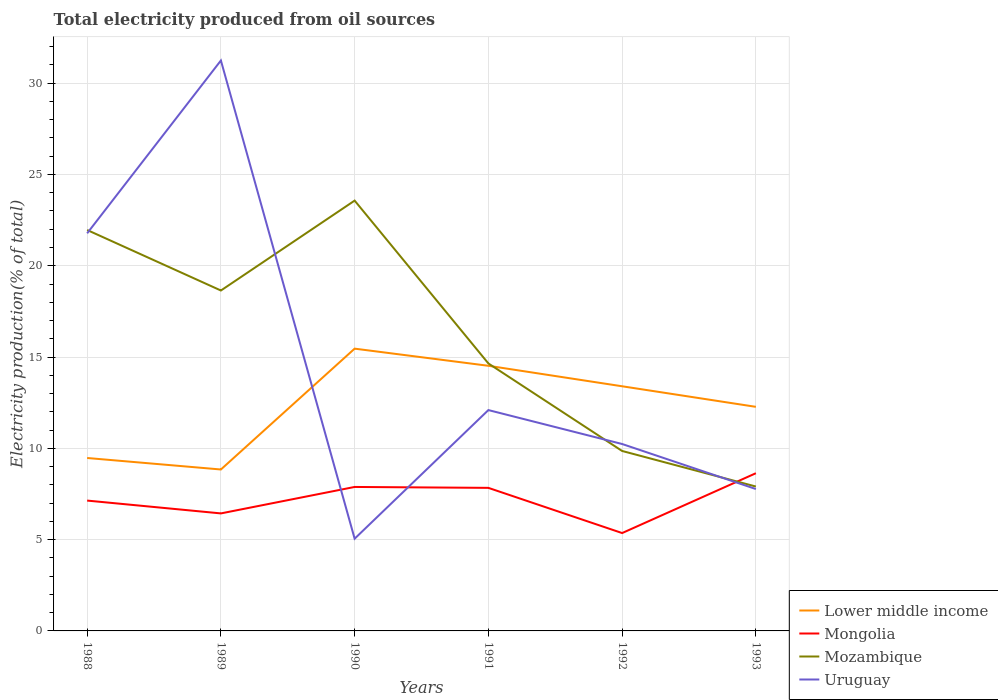Across all years, what is the maximum total electricity produced in Mongolia?
Your answer should be compact. 5.36. In which year was the total electricity produced in Mongolia maximum?
Ensure brevity in your answer.  1992. What is the total total electricity produced in Lower middle income in the graph?
Ensure brevity in your answer.  -3.93. What is the difference between the highest and the second highest total electricity produced in Uruguay?
Give a very brief answer. 26.19. What is the difference between the highest and the lowest total electricity produced in Mozambique?
Your answer should be compact. 3. Is the total electricity produced in Uruguay strictly greater than the total electricity produced in Mozambique over the years?
Give a very brief answer. No. What is the difference between two consecutive major ticks on the Y-axis?
Provide a short and direct response. 5. Does the graph contain any zero values?
Offer a very short reply. No. Does the graph contain grids?
Make the answer very short. Yes. Where does the legend appear in the graph?
Make the answer very short. Bottom right. How are the legend labels stacked?
Your response must be concise. Vertical. What is the title of the graph?
Provide a succinct answer. Total electricity produced from oil sources. What is the label or title of the X-axis?
Ensure brevity in your answer.  Years. What is the Electricity production(% of total) in Lower middle income in 1988?
Keep it short and to the point. 9.47. What is the Electricity production(% of total) of Mongolia in 1988?
Ensure brevity in your answer.  7.14. What is the Electricity production(% of total) in Mozambique in 1988?
Provide a succinct answer. 21.96. What is the Electricity production(% of total) in Uruguay in 1988?
Offer a terse response. 21.78. What is the Electricity production(% of total) of Lower middle income in 1989?
Ensure brevity in your answer.  8.84. What is the Electricity production(% of total) in Mongolia in 1989?
Keep it short and to the point. 6.44. What is the Electricity production(% of total) of Mozambique in 1989?
Provide a succinct answer. 18.64. What is the Electricity production(% of total) in Uruguay in 1989?
Provide a short and direct response. 31.24. What is the Electricity production(% of total) of Lower middle income in 1990?
Your response must be concise. 15.46. What is the Electricity production(% of total) in Mongolia in 1990?
Keep it short and to the point. 7.89. What is the Electricity production(% of total) in Mozambique in 1990?
Your answer should be compact. 23.57. What is the Electricity production(% of total) of Uruguay in 1990?
Offer a very short reply. 5.05. What is the Electricity production(% of total) in Lower middle income in 1991?
Your answer should be compact. 14.52. What is the Electricity production(% of total) of Mongolia in 1991?
Your answer should be very brief. 7.84. What is the Electricity production(% of total) in Mozambique in 1991?
Provide a short and direct response. 14.65. What is the Electricity production(% of total) in Uruguay in 1991?
Keep it short and to the point. 12.1. What is the Electricity production(% of total) of Lower middle income in 1992?
Offer a very short reply. 13.4. What is the Electricity production(% of total) in Mongolia in 1992?
Your response must be concise. 5.36. What is the Electricity production(% of total) of Mozambique in 1992?
Give a very brief answer. 9.86. What is the Electricity production(% of total) of Uruguay in 1992?
Offer a terse response. 10.24. What is the Electricity production(% of total) of Lower middle income in 1993?
Your answer should be very brief. 12.27. What is the Electricity production(% of total) in Mongolia in 1993?
Your response must be concise. 8.64. What is the Electricity production(% of total) of Mozambique in 1993?
Offer a very short reply. 7.91. What is the Electricity production(% of total) in Uruguay in 1993?
Give a very brief answer. 7.77. Across all years, what is the maximum Electricity production(% of total) of Lower middle income?
Provide a succinct answer. 15.46. Across all years, what is the maximum Electricity production(% of total) of Mongolia?
Give a very brief answer. 8.64. Across all years, what is the maximum Electricity production(% of total) in Mozambique?
Ensure brevity in your answer.  23.57. Across all years, what is the maximum Electricity production(% of total) of Uruguay?
Ensure brevity in your answer.  31.24. Across all years, what is the minimum Electricity production(% of total) of Lower middle income?
Your answer should be compact. 8.84. Across all years, what is the minimum Electricity production(% of total) in Mongolia?
Your answer should be compact. 5.36. Across all years, what is the minimum Electricity production(% of total) in Mozambique?
Provide a short and direct response. 7.91. Across all years, what is the minimum Electricity production(% of total) in Uruguay?
Offer a terse response. 5.05. What is the total Electricity production(% of total) of Lower middle income in the graph?
Make the answer very short. 73.97. What is the total Electricity production(% of total) in Mongolia in the graph?
Your answer should be very brief. 43.29. What is the total Electricity production(% of total) of Mozambique in the graph?
Offer a terse response. 96.58. What is the total Electricity production(% of total) in Uruguay in the graph?
Your answer should be compact. 88.17. What is the difference between the Electricity production(% of total) of Lower middle income in 1988 and that in 1989?
Ensure brevity in your answer.  0.63. What is the difference between the Electricity production(% of total) in Mongolia in 1988 and that in 1989?
Give a very brief answer. 0.7. What is the difference between the Electricity production(% of total) in Mozambique in 1988 and that in 1989?
Provide a succinct answer. 3.31. What is the difference between the Electricity production(% of total) of Uruguay in 1988 and that in 1989?
Keep it short and to the point. -9.47. What is the difference between the Electricity production(% of total) in Lower middle income in 1988 and that in 1990?
Ensure brevity in your answer.  -5.99. What is the difference between the Electricity production(% of total) in Mongolia in 1988 and that in 1990?
Provide a succinct answer. -0.75. What is the difference between the Electricity production(% of total) of Mozambique in 1988 and that in 1990?
Provide a succinct answer. -1.61. What is the difference between the Electricity production(% of total) of Uruguay in 1988 and that in 1990?
Give a very brief answer. 16.72. What is the difference between the Electricity production(% of total) in Lower middle income in 1988 and that in 1991?
Provide a short and direct response. -5.05. What is the difference between the Electricity production(% of total) in Mongolia in 1988 and that in 1991?
Your answer should be very brief. -0.7. What is the difference between the Electricity production(% of total) in Mozambique in 1988 and that in 1991?
Make the answer very short. 7.31. What is the difference between the Electricity production(% of total) in Uruguay in 1988 and that in 1991?
Keep it short and to the point. 9.68. What is the difference between the Electricity production(% of total) of Lower middle income in 1988 and that in 1992?
Keep it short and to the point. -3.93. What is the difference between the Electricity production(% of total) of Mongolia in 1988 and that in 1992?
Keep it short and to the point. 1.78. What is the difference between the Electricity production(% of total) of Mozambique in 1988 and that in 1992?
Offer a very short reply. 12.1. What is the difference between the Electricity production(% of total) in Uruguay in 1988 and that in 1992?
Your answer should be compact. 11.54. What is the difference between the Electricity production(% of total) of Lower middle income in 1988 and that in 1993?
Your response must be concise. -2.8. What is the difference between the Electricity production(% of total) in Mongolia in 1988 and that in 1993?
Give a very brief answer. -1.5. What is the difference between the Electricity production(% of total) of Mozambique in 1988 and that in 1993?
Provide a succinct answer. 14.05. What is the difference between the Electricity production(% of total) of Uruguay in 1988 and that in 1993?
Your response must be concise. 14. What is the difference between the Electricity production(% of total) of Lower middle income in 1989 and that in 1990?
Ensure brevity in your answer.  -6.62. What is the difference between the Electricity production(% of total) in Mongolia in 1989 and that in 1990?
Keep it short and to the point. -1.45. What is the difference between the Electricity production(% of total) in Mozambique in 1989 and that in 1990?
Provide a succinct answer. -4.92. What is the difference between the Electricity production(% of total) of Uruguay in 1989 and that in 1990?
Offer a terse response. 26.19. What is the difference between the Electricity production(% of total) of Lower middle income in 1989 and that in 1991?
Ensure brevity in your answer.  -5.68. What is the difference between the Electricity production(% of total) in Mongolia in 1989 and that in 1991?
Offer a very short reply. -1.4. What is the difference between the Electricity production(% of total) in Mozambique in 1989 and that in 1991?
Offer a very short reply. 3.99. What is the difference between the Electricity production(% of total) in Uruguay in 1989 and that in 1991?
Provide a short and direct response. 19.15. What is the difference between the Electricity production(% of total) of Lower middle income in 1989 and that in 1992?
Make the answer very short. -4.56. What is the difference between the Electricity production(% of total) in Mongolia in 1989 and that in 1992?
Your answer should be very brief. 1.08. What is the difference between the Electricity production(% of total) in Mozambique in 1989 and that in 1992?
Your answer should be compact. 8.79. What is the difference between the Electricity production(% of total) in Uruguay in 1989 and that in 1992?
Make the answer very short. 21.01. What is the difference between the Electricity production(% of total) of Lower middle income in 1989 and that in 1993?
Make the answer very short. -3.43. What is the difference between the Electricity production(% of total) of Mongolia in 1989 and that in 1993?
Offer a terse response. -2.2. What is the difference between the Electricity production(% of total) of Mozambique in 1989 and that in 1993?
Your response must be concise. 10.74. What is the difference between the Electricity production(% of total) of Uruguay in 1989 and that in 1993?
Provide a succinct answer. 23.47. What is the difference between the Electricity production(% of total) in Lower middle income in 1990 and that in 1991?
Your response must be concise. 0.94. What is the difference between the Electricity production(% of total) of Mongolia in 1990 and that in 1991?
Keep it short and to the point. 0.05. What is the difference between the Electricity production(% of total) in Mozambique in 1990 and that in 1991?
Your response must be concise. 8.92. What is the difference between the Electricity production(% of total) in Uruguay in 1990 and that in 1991?
Make the answer very short. -7.04. What is the difference between the Electricity production(% of total) of Lower middle income in 1990 and that in 1992?
Your answer should be very brief. 2.06. What is the difference between the Electricity production(% of total) in Mongolia in 1990 and that in 1992?
Ensure brevity in your answer.  2.53. What is the difference between the Electricity production(% of total) of Mozambique in 1990 and that in 1992?
Your answer should be very brief. 13.71. What is the difference between the Electricity production(% of total) in Uruguay in 1990 and that in 1992?
Your answer should be compact. -5.19. What is the difference between the Electricity production(% of total) in Lower middle income in 1990 and that in 1993?
Provide a succinct answer. 3.19. What is the difference between the Electricity production(% of total) in Mongolia in 1990 and that in 1993?
Offer a very short reply. -0.75. What is the difference between the Electricity production(% of total) of Mozambique in 1990 and that in 1993?
Offer a very short reply. 15.66. What is the difference between the Electricity production(% of total) in Uruguay in 1990 and that in 1993?
Provide a succinct answer. -2.72. What is the difference between the Electricity production(% of total) of Lower middle income in 1991 and that in 1992?
Your response must be concise. 1.12. What is the difference between the Electricity production(% of total) in Mongolia in 1991 and that in 1992?
Provide a succinct answer. 2.48. What is the difference between the Electricity production(% of total) in Mozambique in 1991 and that in 1992?
Provide a succinct answer. 4.79. What is the difference between the Electricity production(% of total) of Uruguay in 1991 and that in 1992?
Your answer should be very brief. 1.86. What is the difference between the Electricity production(% of total) of Lower middle income in 1991 and that in 1993?
Make the answer very short. 2.25. What is the difference between the Electricity production(% of total) in Mongolia in 1991 and that in 1993?
Offer a terse response. -0.8. What is the difference between the Electricity production(% of total) in Mozambique in 1991 and that in 1993?
Offer a terse response. 6.74. What is the difference between the Electricity production(% of total) in Uruguay in 1991 and that in 1993?
Provide a succinct answer. 4.32. What is the difference between the Electricity production(% of total) of Lower middle income in 1992 and that in 1993?
Provide a short and direct response. 1.13. What is the difference between the Electricity production(% of total) in Mongolia in 1992 and that in 1993?
Your answer should be very brief. -3.28. What is the difference between the Electricity production(% of total) in Mozambique in 1992 and that in 1993?
Give a very brief answer. 1.95. What is the difference between the Electricity production(% of total) of Uruguay in 1992 and that in 1993?
Make the answer very short. 2.47. What is the difference between the Electricity production(% of total) in Lower middle income in 1988 and the Electricity production(% of total) in Mongolia in 1989?
Your response must be concise. 3.04. What is the difference between the Electricity production(% of total) of Lower middle income in 1988 and the Electricity production(% of total) of Mozambique in 1989?
Your response must be concise. -9.17. What is the difference between the Electricity production(% of total) of Lower middle income in 1988 and the Electricity production(% of total) of Uruguay in 1989?
Provide a succinct answer. -21.77. What is the difference between the Electricity production(% of total) in Mongolia in 1988 and the Electricity production(% of total) in Mozambique in 1989?
Make the answer very short. -11.51. What is the difference between the Electricity production(% of total) in Mongolia in 1988 and the Electricity production(% of total) in Uruguay in 1989?
Provide a short and direct response. -24.1. What is the difference between the Electricity production(% of total) in Mozambique in 1988 and the Electricity production(% of total) in Uruguay in 1989?
Your answer should be compact. -9.28. What is the difference between the Electricity production(% of total) in Lower middle income in 1988 and the Electricity production(% of total) in Mongolia in 1990?
Your answer should be very brief. 1.59. What is the difference between the Electricity production(% of total) of Lower middle income in 1988 and the Electricity production(% of total) of Mozambique in 1990?
Provide a short and direct response. -14.1. What is the difference between the Electricity production(% of total) in Lower middle income in 1988 and the Electricity production(% of total) in Uruguay in 1990?
Keep it short and to the point. 4.42. What is the difference between the Electricity production(% of total) in Mongolia in 1988 and the Electricity production(% of total) in Mozambique in 1990?
Your answer should be compact. -16.43. What is the difference between the Electricity production(% of total) in Mongolia in 1988 and the Electricity production(% of total) in Uruguay in 1990?
Your response must be concise. 2.09. What is the difference between the Electricity production(% of total) in Mozambique in 1988 and the Electricity production(% of total) in Uruguay in 1990?
Ensure brevity in your answer.  16.91. What is the difference between the Electricity production(% of total) in Lower middle income in 1988 and the Electricity production(% of total) in Mongolia in 1991?
Your answer should be very brief. 1.64. What is the difference between the Electricity production(% of total) of Lower middle income in 1988 and the Electricity production(% of total) of Mozambique in 1991?
Your response must be concise. -5.18. What is the difference between the Electricity production(% of total) of Lower middle income in 1988 and the Electricity production(% of total) of Uruguay in 1991?
Provide a succinct answer. -2.62. What is the difference between the Electricity production(% of total) in Mongolia in 1988 and the Electricity production(% of total) in Mozambique in 1991?
Provide a short and direct response. -7.51. What is the difference between the Electricity production(% of total) of Mongolia in 1988 and the Electricity production(% of total) of Uruguay in 1991?
Ensure brevity in your answer.  -4.96. What is the difference between the Electricity production(% of total) in Mozambique in 1988 and the Electricity production(% of total) in Uruguay in 1991?
Ensure brevity in your answer.  9.86. What is the difference between the Electricity production(% of total) in Lower middle income in 1988 and the Electricity production(% of total) in Mongolia in 1992?
Offer a very short reply. 4.11. What is the difference between the Electricity production(% of total) of Lower middle income in 1988 and the Electricity production(% of total) of Mozambique in 1992?
Offer a terse response. -0.38. What is the difference between the Electricity production(% of total) in Lower middle income in 1988 and the Electricity production(% of total) in Uruguay in 1992?
Ensure brevity in your answer.  -0.77. What is the difference between the Electricity production(% of total) in Mongolia in 1988 and the Electricity production(% of total) in Mozambique in 1992?
Your answer should be very brief. -2.72. What is the difference between the Electricity production(% of total) of Mongolia in 1988 and the Electricity production(% of total) of Uruguay in 1992?
Your answer should be very brief. -3.1. What is the difference between the Electricity production(% of total) of Mozambique in 1988 and the Electricity production(% of total) of Uruguay in 1992?
Keep it short and to the point. 11.72. What is the difference between the Electricity production(% of total) in Lower middle income in 1988 and the Electricity production(% of total) in Mongolia in 1993?
Your response must be concise. 0.83. What is the difference between the Electricity production(% of total) in Lower middle income in 1988 and the Electricity production(% of total) in Mozambique in 1993?
Provide a short and direct response. 1.56. What is the difference between the Electricity production(% of total) of Lower middle income in 1988 and the Electricity production(% of total) of Uruguay in 1993?
Make the answer very short. 1.7. What is the difference between the Electricity production(% of total) in Mongolia in 1988 and the Electricity production(% of total) in Mozambique in 1993?
Make the answer very short. -0.77. What is the difference between the Electricity production(% of total) of Mongolia in 1988 and the Electricity production(% of total) of Uruguay in 1993?
Your answer should be compact. -0.63. What is the difference between the Electricity production(% of total) in Mozambique in 1988 and the Electricity production(% of total) in Uruguay in 1993?
Offer a very short reply. 14.19. What is the difference between the Electricity production(% of total) of Lower middle income in 1989 and the Electricity production(% of total) of Mongolia in 1990?
Offer a very short reply. 0.96. What is the difference between the Electricity production(% of total) of Lower middle income in 1989 and the Electricity production(% of total) of Mozambique in 1990?
Keep it short and to the point. -14.73. What is the difference between the Electricity production(% of total) of Lower middle income in 1989 and the Electricity production(% of total) of Uruguay in 1990?
Provide a succinct answer. 3.79. What is the difference between the Electricity production(% of total) in Mongolia in 1989 and the Electricity production(% of total) in Mozambique in 1990?
Your answer should be compact. -17.13. What is the difference between the Electricity production(% of total) in Mongolia in 1989 and the Electricity production(% of total) in Uruguay in 1990?
Your answer should be very brief. 1.39. What is the difference between the Electricity production(% of total) in Mozambique in 1989 and the Electricity production(% of total) in Uruguay in 1990?
Your answer should be very brief. 13.59. What is the difference between the Electricity production(% of total) in Lower middle income in 1989 and the Electricity production(% of total) in Mongolia in 1991?
Your answer should be very brief. 1.01. What is the difference between the Electricity production(% of total) in Lower middle income in 1989 and the Electricity production(% of total) in Mozambique in 1991?
Give a very brief answer. -5.81. What is the difference between the Electricity production(% of total) in Lower middle income in 1989 and the Electricity production(% of total) in Uruguay in 1991?
Make the answer very short. -3.25. What is the difference between the Electricity production(% of total) of Mongolia in 1989 and the Electricity production(% of total) of Mozambique in 1991?
Give a very brief answer. -8.21. What is the difference between the Electricity production(% of total) in Mongolia in 1989 and the Electricity production(% of total) in Uruguay in 1991?
Provide a succinct answer. -5.66. What is the difference between the Electricity production(% of total) of Mozambique in 1989 and the Electricity production(% of total) of Uruguay in 1991?
Your answer should be very brief. 6.55. What is the difference between the Electricity production(% of total) in Lower middle income in 1989 and the Electricity production(% of total) in Mongolia in 1992?
Your answer should be very brief. 3.48. What is the difference between the Electricity production(% of total) in Lower middle income in 1989 and the Electricity production(% of total) in Mozambique in 1992?
Offer a very short reply. -1.01. What is the difference between the Electricity production(% of total) in Lower middle income in 1989 and the Electricity production(% of total) in Uruguay in 1992?
Provide a succinct answer. -1.4. What is the difference between the Electricity production(% of total) in Mongolia in 1989 and the Electricity production(% of total) in Mozambique in 1992?
Your answer should be very brief. -3.42. What is the difference between the Electricity production(% of total) in Mongolia in 1989 and the Electricity production(% of total) in Uruguay in 1992?
Offer a very short reply. -3.8. What is the difference between the Electricity production(% of total) in Mozambique in 1989 and the Electricity production(% of total) in Uruguay in 1992?
Make the answer very short. 8.41. What is the difference between the Electricity production(% of total) of Lower middle income in 1989 and the Electricity production(% of total) of Mongolia in 1993?
Make the answer very short. 0.2. What is the difference between the Electricity production(% of total) in Lower middle income in 1989 and the Electricity production(% of total) in Mozambique in 1993?
Ensure brevity in your answer.  0.93. What is the difference between the Electricity production(% of total) of Lower middle income in 1989 and the Electricity production(% of total) of Uruguay in 1993?
Give a very brief answer. 1.07. What is the difference between the Electricity production(% of total) in Mongolia in 1989 and the Electricity production(% of total) in Mozambique in 1993?
Keep it short and to the point. -1.47. What is the difference between the Electricity production(% of total) in Mongolia in 1989 and the Electricity production(% of total) in Uruguay in 1993?
Your answer should be very brief. -1.34. What is the difference between the Electricity production(% of total) in Mozambique in 1989 and the Electricity production(% of total) in Uruguay in 1993?
Keep it short and to the point. 10.87. What is the difference between the Electricity production(% of total) of Lower middle income in 1990 and the Electricity production(% of total) of Mongolia in 1991?
Keep it short and to the point. 7.62. What is the difference between the Electricity production(% of total) of Lower middle income in 1990 and the Electricity production(% of total) of Mozambique in 1991?
Keep it short and to the point. 0.81. What is the difference between the Electricity production(% of total) in Lower middle income in 1990 and the Electricity production(% of total) in Uruguay in 1991?
Provide a short and direct response. 3.36. What is the difference between the Electricity production(% of total) in Mongolia in 1990 and the Electricity production(% of total) in Mozambique in 1991?
Provide a succinct answer. -6.76. What is the difference between the Electricity production(% of total) in Mongolia in 1990 and the Electricity production(% of total) in Uruguay in 1991?
Ensure brevity in your answer.  -4.21. What is the difference between the Electricity production(% of total) in Mozambique in 1990 and the Electricity production(% of total) in Uruguay in 1991?
Make the answer very short. 11.47. What is the difference between the Electricity production(% of total) in Lower middle income in 1990 and the Electricity production(% of total) in Mongolia in 1992?
Your answer should be compact. 10.1. What is the difference between the Electricity production(% of total) in Lower middle income in 1990 and the Electricity production(% of total) in Mozambique in 1992?
Your answer should be compact. 5.6. What is the difference between the Electricity production(% of total) in Lower middle income in 1990 and the Electricity production(% of total) in Uruguay in 1992?
Keep it short and to the point. 5.22. What is the difference between the Electricity production(% of total) of Mongolia in 1990 and the Electricity production(% of total) of Mozambique in 1992?
Offer a very short reply. -1.97. What is the difference between the Electricity production(% of total) in Mongolia in 1990 and the Electricity production(% of total) in Uruguay in 1992?
Keep it short and to the point. -2.35. What is the difference between the Electricity production(% of total) of Mozambique in 1990 and the Electricity production(% of total) of Uruguay in 1992?
Your response must be concise. 13.33. What is the difference between the Electricity production(% of total) in Lower middle income in 1990 and the Electricity production(% of total) in Mongolia in 1993?
Keep it short and to the point. 6.82. What is the difference between the Electricity production(% of total) in Lower middle income in 1990 and the Electricity production(% of total) in Mozambique in 1993?
Ensure brevity in your answer.  7.55. What is the difference between the Electricity production(% of total) in Lower middle income in 1990 and the Electricity production(% of total) in Uruguay in 1993?
Make the answer very short. 7.69. What is the difference between the Electricity production(% of total) of Mongolia in 1990 and the Electricity production(% of total) of Mozambique in 1993?
Provide a succinct answer. -0.02. What is the difference between the Electricity production(% of total) in Mongolia in 1990 and the Electricity production(% of total) in Uruguay in 1993?
Offer a very short reply. 0.11. What is the difference between the Electricity production(% of total) of Mozambique in 1990 and the Electricity production(% of total) of Uruguay in 1993?
Your response must be concise. 15.8. What is the difference between the Electricity production(% of total) of Lower middle income in 1991 and the Electricity production(% of total) of Mongolia in 1992?
Offer a very short reply. 9.16. What is the difference between the Electricity production(% of total) in Lower middle income in 1991 and the Electricity production(% of total) in Mozambique in 1992?
Your answer should be compact. 4.67. What is the difference between the Electricity production(% of total) in Lower middle income in 1991 and the Electricity production(% of total) in Uruguay in 1992?
Ensure brevity in your answer.  4.28. What is the difference between the Electricity production(% of total) of Mongolia in 1991 and the Electricity production(% of total) of Mozambique in 1992?
Keep it short and to the point. -2.02. What is the difference between the Electricity production(% of total) in Mongolia in 1991 and the Electricity production(% of total) in Uruguay in 1992?
Make the answer very short. -2.4. What is the difference between the Electricity production(% of total) in Mozambique in 1991 and the Electricity production(% of total) in Uruguay in 1992?
Provide a short and direct response. 4.41. What is the difference between the Electricity production(% of total) of Lower middle income in 1991 and the Electricity production(% of total) of Mongolia in 1993?
Your answer should be very brief. 5.88. What is the difference between the Electricity production(% of total) in Lower middle income in 1991 and the Electricity production(% of total) in Mozambique in 1993?
Give a very brief answer. 6.61. What is the difference between the Electricity production(% of total) of Lower middle income in 1991 and the Electricity production(% of total) of Uruguay in 1993?
Your answer should be very brief. 6.75. What is the difference between the Electricity production(% of total) of Mongolia in 1991 and the Electricity production(% of total) of Mozambique in 1993?
Your response must be concise. -0.07. What is the difference between the Electricity production(% of total) of Mongolia in 1991 and the Electricity production(% of total) of Uruguay in 1993?
Give a very brief answer. 0.06. What is the difference between the Electricity production(% of total) of Mozambique in 1991 and the Electricity production(% of total) of Uruguay in 1993?
Provide a succinct answer. 6.88. What is the difference between the Electricity production(% of total) in Lower middle income in 1992 and the Electricity production(% of total) in Mongolia in 1993?
Your answer should be compact. 4.76. What is the difference between the Electricity production(% of total) in Lower middle income in 1992 and the Electricity production(% of total) in Mozambique in 1993?
Keep it short and to the point. 5.49. What is the difference between the Electricity production(% of total) in Lower middle income in 1992 and the Electricity production(% of total) in Uruguay in 1993?
Make the answer very short. 5.63. What is the difference between the Electricity production(% of total) of Mongolia in 1992 and the Electricity production(% of total) of Mozambique in 1993?
Your response must be concise. -2.55. What is the difference between the Electricity production(% of total) in Mongolia in 1992 and the Electricity production(% of total) in Uruguay in 1993?
Your response must be concise. -2.41. What is the difference between the Electricity production(% of total) of Mozambique in 1992 and the Electricity production(% of total) of Uruguay in 1993?
Make the answer very short. 2.08. What is the average Electricity production(% of total) in Lower middle income per year?
Make the answer very short. 12.33. What is the average Electricity production(% of total) in Mongolia per year?
Your answer should be very brief. 7.22. What is the average Electricity production(% of total) in Mozambique per year?
Offer a terse response. 16.1. What is the average Electricity production(% of total) of Uruguay per year?
Your answer should be very brief. 14.7. In the year 1988, what is the difference between the Electricity production(% of total) in Lower middle income and Electricity production(% of total) in Mongolia?
Make the answer very short. 2.33. In the year 1988, what is the difference between the Electricity production(% of total) in Lower middle income and Electricity production(% of total) in Mozambique?
Offer a terse response. -12.49. In the year 1988, what is the difference between the Electricity production(% of total) of Lower middle income and Electricity production(% of total) of Uruguay?
Ensure brevity in your answer.  -12.3. In the year 1988, what is the difference between the Electricity production(% of total) in Mongolia and Electricity production(% of total) in Mozambique?
Offer a terse response. -14.82. In the year 1988, what is the difference between the Electricity production(% of total) of Mongolia and Electricity production(% of total) of Uruguay?
Ensure brevity in your answer.  -14.64. In the year 1988, what is the difference between the Electricity production(% of total) in Mozambique and Electricity production(% of total) in Uruguay?
Your response must be concise. 0.18. In the year 1989, what is the difference between the Electricity production(% of total) in Lower middle income and Electricity production(% of total) in Mongolia?
Ensure brevity in your answer.  2.4. In the year 1989, what is the difference between the Electricity production(% of total) in Lower middle income and Electricity production(% of total) in Mozambique?
Provide a short and direct response. -9.8. In the year 1989, what is the difference between the Electricity production(% of total) of Lower middle income and Electricity production(% of total) of Uruguay?
Make the answer very short. -22.4. In the year 1989, what is the difference between the Electricity production(% of total) of Mongolia and Electricity production(% of total) of Mozambique?
Your answer should be very brief. -12.21. In the year 1989, what is the difference between the Electricity production(% of total) of Mongolia and Electricity production(% of total) of Uruguay?
Your answer should be compact. -24.81. In the year 1989, what is the difference between the Electricity production(% of total) in Mozambique and Electricity production(% of total) in Uruguay?
Your response must be concise. -12.6. In the year 1990, what is the difference between the Electricity production(% of total) in Lower middle income and Electricity production(% of total) in Mongolia?
Your answer should be compact. 7.57. In the year 1990, what is the difference between the Electricity production(% of total) in Lower middle income and Electricity production(% of total) in Mozambique?
Keep it short and to the point. -8.11. In the year 1990, what is the difference between the Electricity production(% of total) of Lower middle income and Electricity production(% of total) of Uruguay?
Keep it short and to the point. 10.41. In the year 1990, what is the difference between the Electricity production(% of total) of Mongolia and Electricity production(% of total) of Mozambique?
Your answer should be compact. -15.68. In the year 1990, what is the difference between the Electricity production(% of total) of Mongolia and Electricity production(% of total) of Uruguay?
Give a very brief answer. 2.83. In the year 1990, what is the difference between the Electricity production(% of total) of Mozambique and Electricity production(% of total) of Uruguay?
Make the answer very short. 18.52. In the year 1991, what is the difference between the Electricity production(% of total) in Lower middle income and Electricity production(% of total) in Mongolia?
Make the answer very short. 6.69. In the year 1991, what is the difference between the Electricity production(% of total) of Lower middle income and Electricity production(% of total) of Mozambique?
Your response must be concise. -0.13. In the year 1991, what is the difference between the Electricity production(% of total) in Lower middle income and Electricity production(% of total) in Uruguay?
Your answer should be compact. 2.43. In the year 1991, what is the difference between the Electricity production(% of total) of Mongolia and Electricity production(% of total) of Mozambique?
Ensure brevity in your answer.  -6.81. In the year 1991, what is the difference between the Electricity production(% of total) of Mongolia and Electricity production(% of total) of Uruguay?
Make the answer very short. -4.26. In the year 1991, what is the difference between the Electricity production(% of total) in Mozambique and Electricity production(% of total) in Uruguay?
Ensure brevity in your answer.  2.55. In the year 1992, what is the difference between the Electricity production(% of total) of Lower middle income and Electricity production(% of total) of Mongolia?
Offer a terse response. 8.04. In the year 1992, what is the difference between the Electricity production(% of total) in Lower middle income and Electricity production(% of total) in Mozambique?
Your response must be concise. 3.54. In the year 1992, what is the difference between the Electricity production(% of total) of Lower middle income and Electricity production(% of total) of Uruguay?
Ensure brevity in your answer.  3.16. In the year 1992, what is the difference between the Electricity production(% of total) of Mongolia and Electricity production(% of total) of Mozambique?
Offer a terse response. -4.5. In the year 1992, what is the difference between the Electricity production(% of total) in Mongolia and Electricity production(% of total) in Uruguay?
Your answer should be compact. -4.88. In the year 1992, what is the difference between the Electricity production(% of total) of Mozambique and Electricity production(% of total) of Uruguay?
Offer a very short reply. -0.38. In the year 1993, what is the difference between the Electricity production(% of total) of Lower middle income and Electricity production(% of total) of Mongolia?
Your response must be concise. 3.64. In the year 1993, what is the difference between the Electricity production(% of total) of Lower middle income and Electricity production(% of total) of Mozambique?
Give a very brief answer. 4.36. In the year 1993, what is the difference between the Electricity production(% of total) of Lower middle income and Electricity production(% of total) of Uruguay?
Your response must be concise. 4.5. In the year 1993, what is the difference between the Electricity production(% of total) in Mongolia and Electricity production(% of total) in Mozambique?
Your answer should be very brief. 0.73. In the year 1993, what is the difference between the Electricity production(% of total) in Mongolia and Electricity production(% of total) in Uruguay?
Keep it short and to the point. 0.87. In the year 1993, what is the difference between the Electricity production(% of total) in Mozambique and Electricity production(% of total) in Uruguay?
Your response must be concise. 0.14. What is the ratio of the Electricity production(% of total) in Lower middle income in 1988 to that in 1989?
Your response must be concise. 1.07. What is the ratio of the Electricity production(% of total) of Mongolia in 1988 to that in 1989?
Offer a very short reply. 1.11. What is the ratio of the Electricity production(% of total) in Mozambique in 1988 to that in 1989?
Your response must be concise. 1.18. What is the ratio of the Electricity production(% of total) in Uruguay in 1988 to that in 1989?
Your answer should be very brief. 0.7. What is the ratio of the Electricity production(% of total) in Lower middle income in 1988 to that in 1990?
Your response must be concise. 0.61. What is the ratio of the Electricity production(% of total) of Mongolia in 1988 to that in 1990?
Offer a terse response. 0.91. What is the ratio of the Electricity production(% of total) of Mozambique in 1988 to that in 1990?
Provide a short and direct response. 0.93. What is the ratio of the Electricity production(% of total) of Uruguay in 1988 to that in 1990?
Keep it short and to the point. 4.31. What is the ratio of the Electricity production(% of total) of Lower middle income in 1988 to that in 1991?
Your answer should be very brief. 0.65. What is the ratio of the Electricity production(% of total) of Mongolia in 1988 to that in 1991?
Provide a short and direct response. 0.91. What is the ratio of the Electricity production(% of total) in Mozambique in 1988 to that in 1991?
Your answer should be compact. 1.5. What is the ratio of the Electricity production(% of total) in Uruguay in 1988 to that in 1991?
Offer a very short reply. 1.8. What is the ratio of the Electricity production(% of total) in Lower middle income in 1988 to that in 1992?
Offer a very short reply. 0.71. What is the ratio of the Electricity production(% of total) of Mongolia in 1988 to that in 1992?
Provide a short and direct response. 1.33. What is the ratio of the Electricity production(% of total) of Mozambique in 1988 to that in 1992?
Offer a terse response. 2.23. What is the ratio of the Electricity production(% of total) in Uruguay in 1988 to that in 1992?
Ensure brevity in your answer.  2.13. What is the ratio of the Electricity production(% of total) in Lower middle income in 1988 to that in 1993?
Your response must be concise. 0.77. What is the ratio of the Electricity production(% of total) of Mongolia in 1988 to that in 1993?
Keep it short and to the point. 0.83. What is the ratio of the Electricity production(% of total) of Mozambique in 1988 to that in 1993?
Offer a terse response. 2.78. What is the ratio of the Electricity production(% of total) in Uruguay in 1988 to that in 1993?
Your answer should be very brief. 2.8. What is the ratio of the Electricity production(% of total) of Lower middle income in 1989 to that in 1990?
Give a very brief answer. 0.57. What is the ratio of the Electricity production(% of total) in Mongolia in 1989 to that in 1990?
Your answer should be compact. 0.82. What is the ratio of the Electricity production(% of total) of Mozambique in 1989 to that in 1990?
Your response must be concise. 0.79. What is the ratio of the Electricity production(% of total) of Uruguay in 1989 to that in 1990?
Your response must be concise. 6.19. What is the ratio of the Electricity production(% of total) of Lower middle income in 1989 to that in 1991?
Ensure brevity in your answer.  0.61. What is the ratio of the Electricity production(% of total) of Mongolia in 1989 to that in 1991?
Offer a terse response. 0.82. What is the ratio of the Electricity production(% of total) in Mozambique in 1989 to that in 1991?
Offer a very short reply. 1.27. What is the ratio of the Electricity production(% of total) in Uruguay in 1989 to that in 1991?
Make the answer very short. 2.58. What is the ratio of the Electricity production(% of total) in Lower middle income in 1989 to that in 1992?
Offer a terse response. 0.66. What is the ratio of the Electricity production(% of total) in Mongolia in 1989 to that in 1992?
Your response must be concise. 1.2. What is the ratio of the Electricity production(% of total) of Mozambique in 1989 to that in 1992?
Make the answer very short. 1.89. What is the ratio of the Electricity production(% of total) in Uruguay in 1989 to that in 1992?
Your response must be concise. 3.05. What is the ratio of the Electricity production(% of total) of Lower middle income in 1989 to that in 1993?
Provide a short and direct response. 0.72. What is the ratio of the Electricity production(% of total) in Mongolia in 1989 to that in 1993?
Your response must be concise. 0.75. What is the ratio of the Electricity production(% of total) in Mozambique in 1989 to that in 1993?
Give a very brief answer. 2.36. What is the ratio of the Electricity production(% of total) of Uruguay in 1989 to that in 1993?
Your response must be concise. 4.02. What is the ratio of the Electricity production(% of total) of Lower middle income in 1990 to that in 1991?
Your response must be concise. 1.06. What is the ratio of the Electricity production(% of total) in Mongolia in 1990 to that in 1991?
Provide a short and direct response. 1.01. What is the ratio of the Electricity production(% of total) of Mozambique in 1990 to that in 1991?
Offer a terse response. 1.61. What is the ratio of the Electricity production(% of total) in Uruguay in 1990 to that in 1991?
Ensure brevity in your answer.  0.42. What is the ratio of the Electricity production(% of total) of Lower middle income in 1990 to that in 1992?
Give a very brief answer. 1.15. What is the ratio of the Electricity production(% of total) of Mongolia in 1990 to that in 1992?
Keep it short and to the point. 1.47. What is the ratio of the Electricity production(% of total) in Mozambique in 1990 to that in 1992?
Ensure brevity in your answer.  2.39. What is the ratio of the Electricity production(% of total) of Uruguay in 1990 to that in 1992?
Your answer should be very brief. 0.49. What is the ratio of the Electricity production(% of total) in Lower middle income in 1990 to that in 1993?
Provide a succinct answer. 1.26. What is the ratio of the Electricity production(% of total) in Mongolia in 1990 to that in 1993?
Offer a very short reply. 0.91. What is the ratio of the Electricity production(% of total) of Mozambique in 1990 to that in 1993?
Provide a short and direct response. 2.98. What is the ratio of the Electricity production(% of total) of Uruguay in 1990 to that in 1993?
Your answer should be very brief. 0.65. What is the ratio of the Electricity production(% of total) in Lower middle income in 1991 to that in 1992?
Keep it short and to the point. 1.08. What is the ratio of the Electricity production(% of total) of Mongolia in 1991 to that in 1992?
Offer a terse response. 1.46. What is the ratio of the Electricity production(% of total) in Mozambique in 1991 to that in 1992?
Provide a succinct answer. 1.49. What is the ratio of the Electricity production(% of total) of Uruguay in 1991 to that in 1992?
Offer a very short reply. 1.18. What is the ratio of the Electricity production(% of total) of Lower middle income in 1991 to that in 1993?
Give a very brief answer. 1.18. What is the ratio of the Electricity production(% of total) in Mongolia in 1991 to that in 1993?
Make the answer very short. 0.91. What is the ratio of the Electricity production(% of total) in Mozambique in 1991 to that in 1993?
Your response must be concise. 1.85. What is the ratio of the Electricity production(% of total) of Uruguay in 1991 to that in 1993?
Your answer should be very brief. 1.56. What is the ratio of the Electricity production(% of total) in Lower middle income in 1992 to that in 1993?
Your answer should be very brief. 1.09. What is the ratio of the Electricity production(% of total) of Mongolia in 1992 to that in 1993?
Your answer should be very brief. 0.62. What is the ratio of the Electricity production(% of total) of Mozambique in 1992 to that in 1993?
Offer a terse response. 1.25. What is the ratio of the Electricity production(% of total) in Uruguay in 1992 to that in 1993?
Provide a succinct answer. 1.32. What is the difference between the highest and the second highest Electricity production(% of total) of Lower middle income?
Make the answer very short. 0.94. What is the difference between the highest and the second highest Electricity production(% of total) of Mongolia?
Offer a terse response. 0.75. What is the difference between the highest and the second highest Electricity production(% of total) in Mozambique?
Your answer should be very brief. 1.61. What is the difference between the highest and the second highest Electricity production(% of total) of Uruguay?
Provide a short and direct response. 9.47. What is the difference between the highest and the lowest Electricity production(% of total) of Lower middle income?
Offer a very short reply. 6.62. What is the difference between the highest and the lowest Electricity production(% of total) in Mongolia?
Give a very brief answer. 3.28. What is the difference between the highest and the lowest Electricity production(% of total) in Mozambique?
Your answer should be compact. 15.66. What is the difference between the highest and the lowest Electricity production(% of total) of Uruguay?
Offer a terse response. 26.19. 